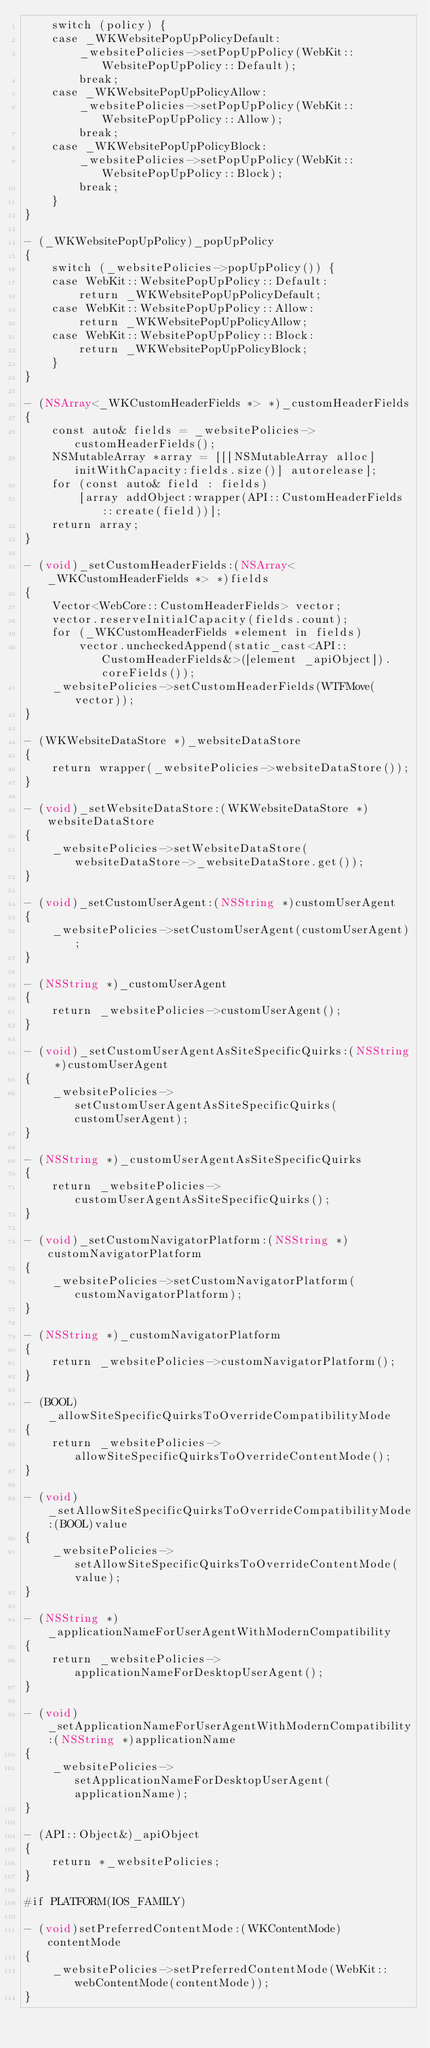Convert code to text. <code><loc_0><loc_0><loc_500><loc_500><_ObjectiveC_>    switch (policy) {
    case _WKWebsitePopUpPolicyDefault:
        _websitePolicies->setPopUpPolicy(WebKit::WebsitePopUpPolicy::Default);
        break;
    case _WKWebsitePopUpPolicyAllow:
        _websitePolicies->setPopUpPolicy(WebKit::WebsitePopUpPolicy::Allow);
        break;
    case _WKWebsitePopUpPolicyBlock:
        _websitePolicies->setPopUpPolicy(WebKit::WebsitePopUpPolicy::Block);
        break;
    }
}

- (_WKWebsitePopUpPolicy)_popUpPolicy
{
    switch (_websitePolicies->popUpPolicy()) {
    case WebKit::WebsitePopUpPolicy::Default:
        return _WKWebsitePopUpPolicyDefault;
    case WebKit::WebsitePopUpPolicy::Allow:
        return _WKWebsitePopUpPolicyAllow;
    case WebKit::WebsitePopUpPolicy::Block:
        return _WKWebsitePopUpPolicyBlock;
    }
}

- (NSArray<_WKCustomHeaderFields *> *)_customHeaderFields
{
    const auto& fields = _websitePolicies->customHeaderFields();
    NSMutableArray *array = [[[NSMutableArray alloc] initWithCapacity:fields.size()] autorelease];
    for (const auto& field : fields)
        [array addObject:wrapper(API::CustomHeaderFields::create(field))];
    return array;
}

- (void)_setCustomHeaderFields:(NSArray<_WKCustomHeaderFields *> *)fields
{
    Vector<WebCore::CustomHeaderFields> vector;
    vector.reserveInitialCapacity(fields.count);
    for (_WKCustomHeaderFields *element in fields)
        vector.uncheckedAppend(static_cast<API::CustomHeaderFields&>([element _apiObject]).coreFields());
    _websitePolicies->setCustomHeaderFields(WTFMove(vector));
}

- (WKWebsiteDataStore *)_websiteDataStore
{
    return wrapper(_websitePolicies->websiteDataStore());
}

- (void)_setWebsiteDataStore:(WKWebsiteDataStore *)websiteDataStore
{
    _websitePolicies->setWebsiteDataStore(websiteDataStore->_websiteDataStore.get());
}

- (void)_setCustomUserAgent:(NSString *)customUserAgent
{
    _websitePolicies->setCustomUserAgent(customUserAgent);
}

- (NSString *)_customUserAgent
{
    return _websitePolicies->customUserAgent();
}

- (void)_setCustomUserAgentAsSiteSpecificQuirks:(NSString *)customUserAgent
{
    _websitePolicies->setCustomUserAgentAsSiteSpecificQuirks(customUserAgent);
}

- (NSString *)_customUserAgentAsSiteSpecificQuirks
{
    return _websitePolicies->customUserAgentAsSiteSpecificQuirks();
}

- (void)_setCustomNavigatorPlatform:(NSString *)customNavigatorPlatform
{
    _websitePolicies->setCustomNavigatorPlatform(customNavigatorPlatform);
}

- (NSString *)_customNavigatorPlatform
{
    return _websitePolicies->customNavigatorPlatform();
}

- (BOOL)_allowSiteSpecificQuirksToOverrideCompatibilityMode
{
    return _websitePolicies->allowSiteSpecificQuirksToOverrideContentMode();
}

- (void)_setAllowSiteSpecificQuirksToOverrideCompatibilityMode:(BOOL)value
{
    _websitePolicies->setAllowSiteSpecificQuirksToOverrideContentMode(value);
}

- (NSString *)_applicationNameForUserAgentWithModernCompatibility
{
    return _websitePolicies->applicationNameForDesktopUserAgent();
}

- (void)_setApplicationNameForUserAgentWithModernCompatibility:(NSString *)applicationName
{
    _websitePolicies->setApplicationNameForDesktopUserAgent(applicationName);
}

- (API::Object&)_apiObject
{
    return *_websitePolicies;
}

#if PLATFORM(IOS_FAMILY)

- (void)setPreferredContentMode:(WKContentMode)contentMode
{
    _websitePolicies->setPreferredContentMode(WebKit::webContentMode(contentMode));
}
</code> 